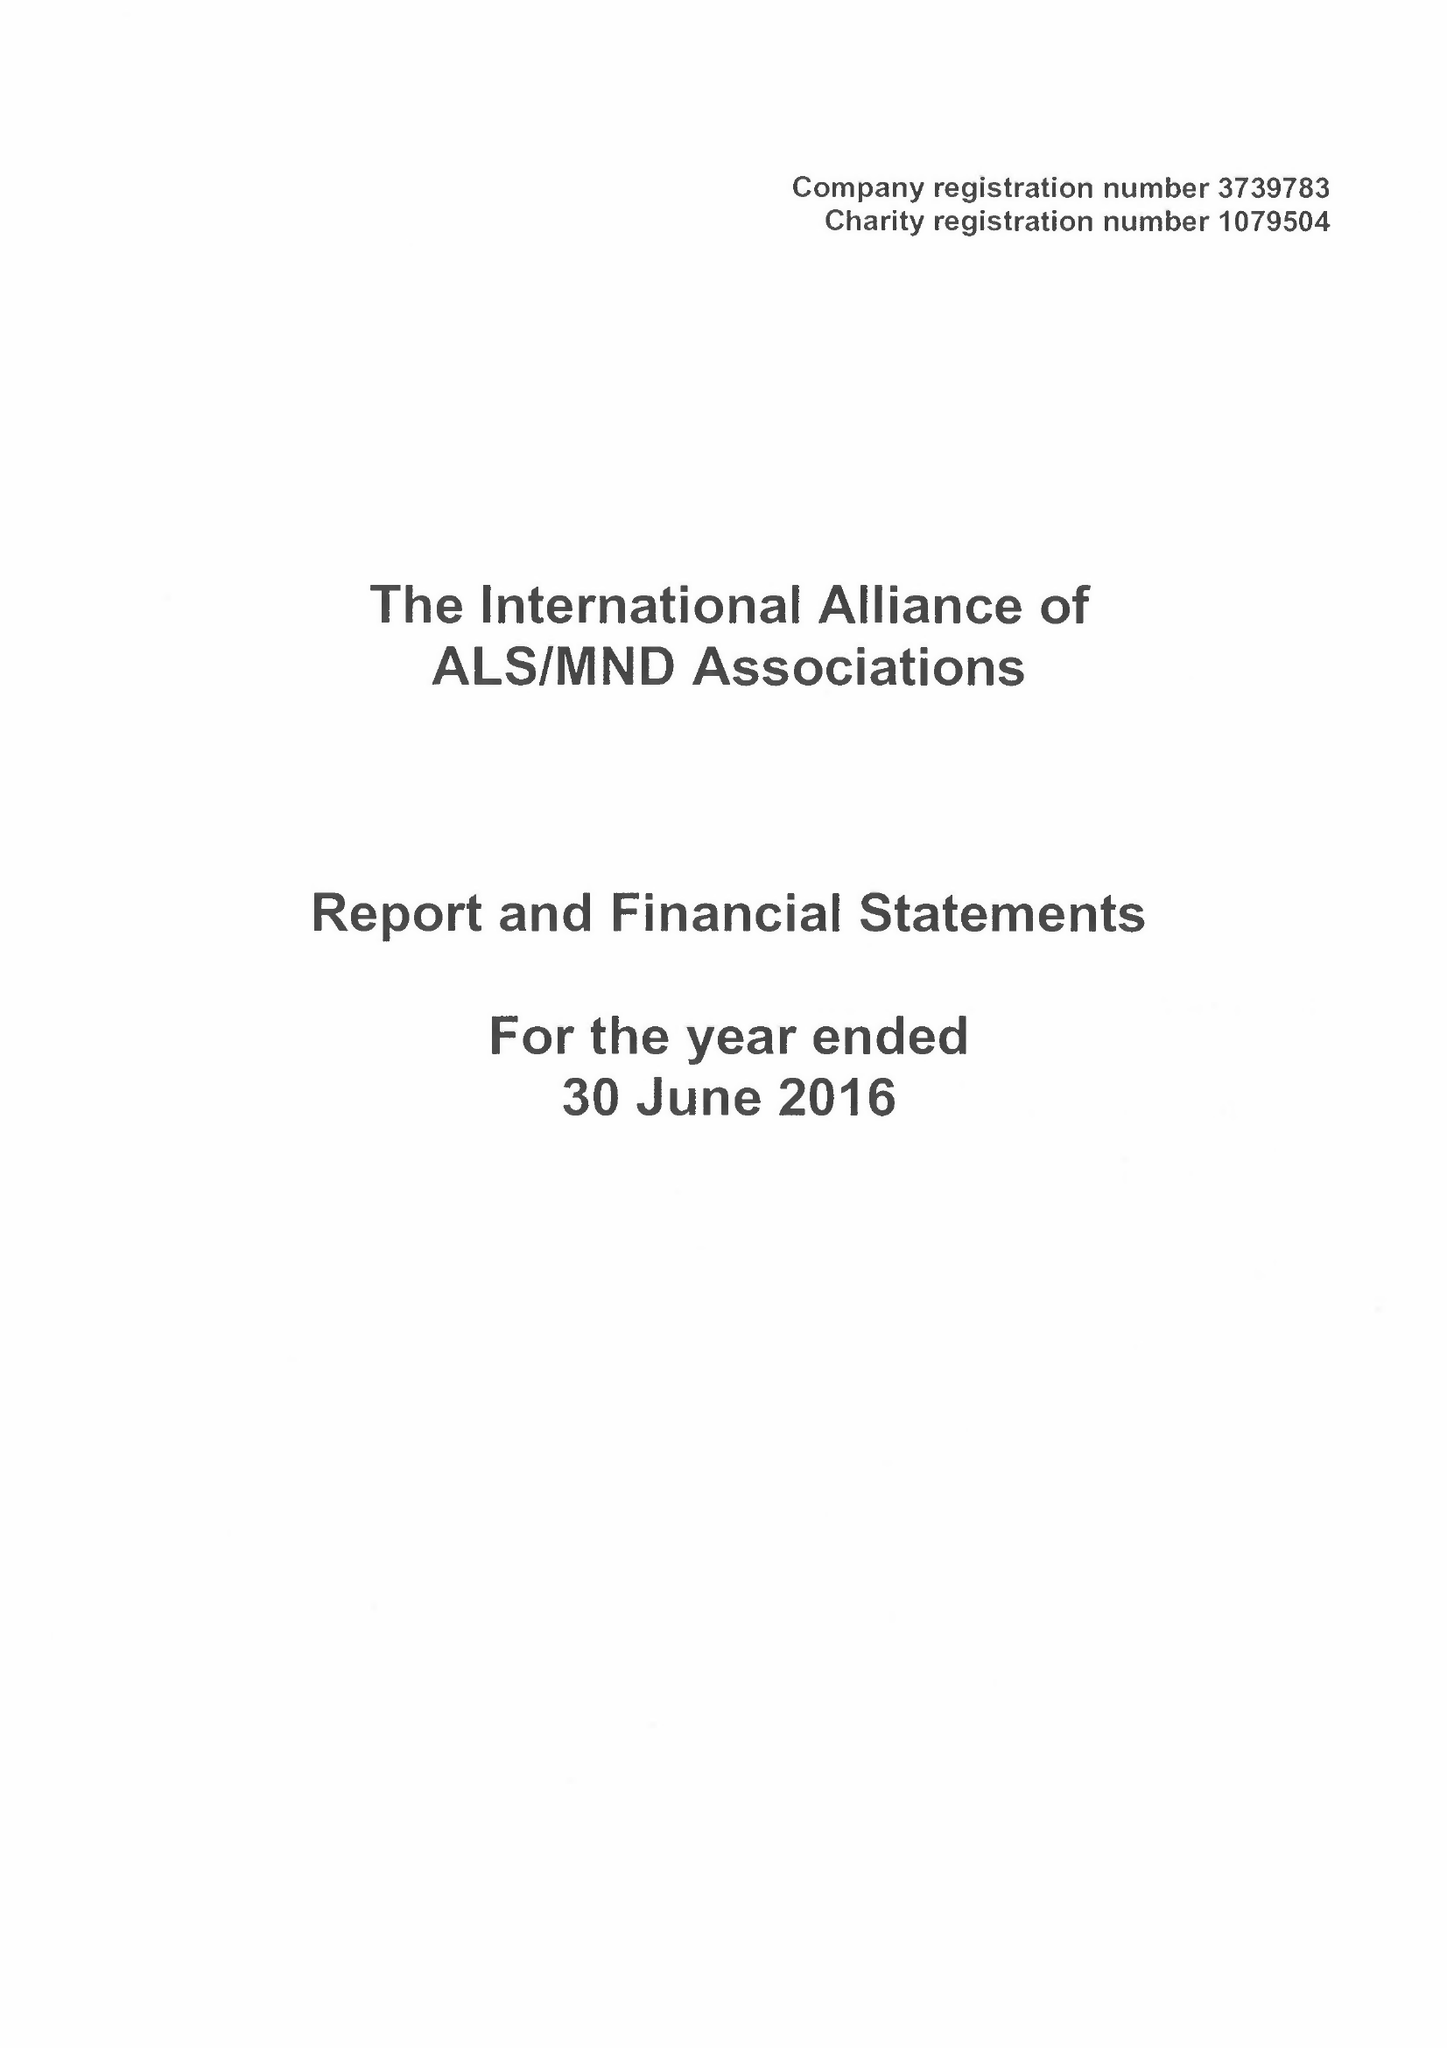What is the value for the charity_name?
Answer the question using a single word or phrase. The International Alliance Of Als / Mnd Associations 